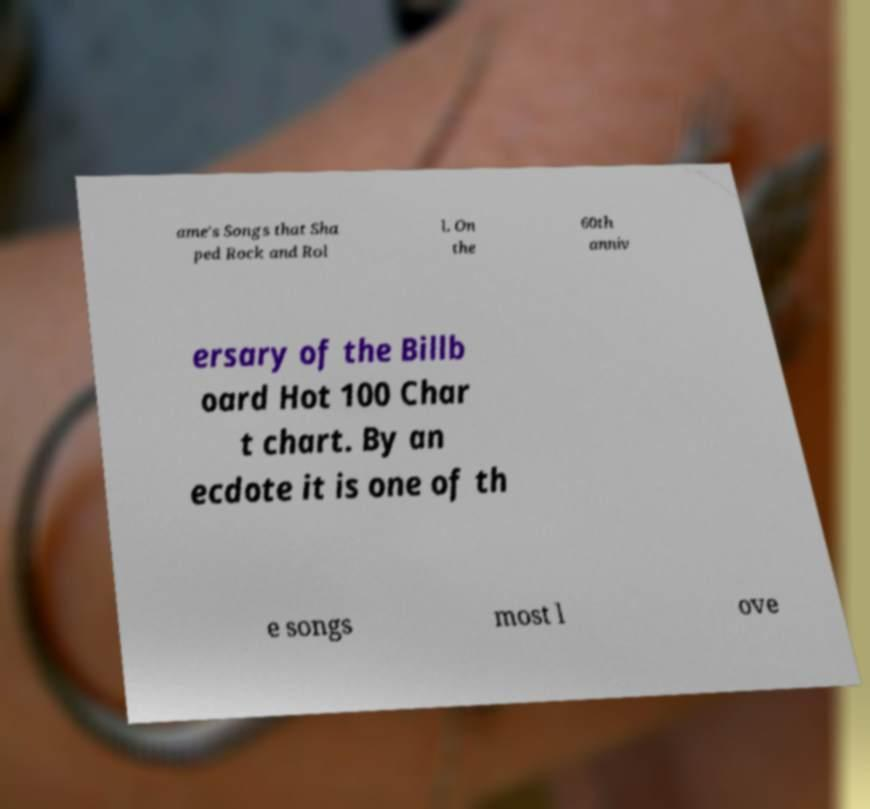Can you read and provide the text displayed in the image?This photo seems to have some interesting text. Can you extract and type it out for me? ame's Songs that Sha ped Rock and Rol l. On the 60th anniv ersary of the Billb oard Hot 100 Char t chart. By an ecdote it is one of th e songs most l ove 